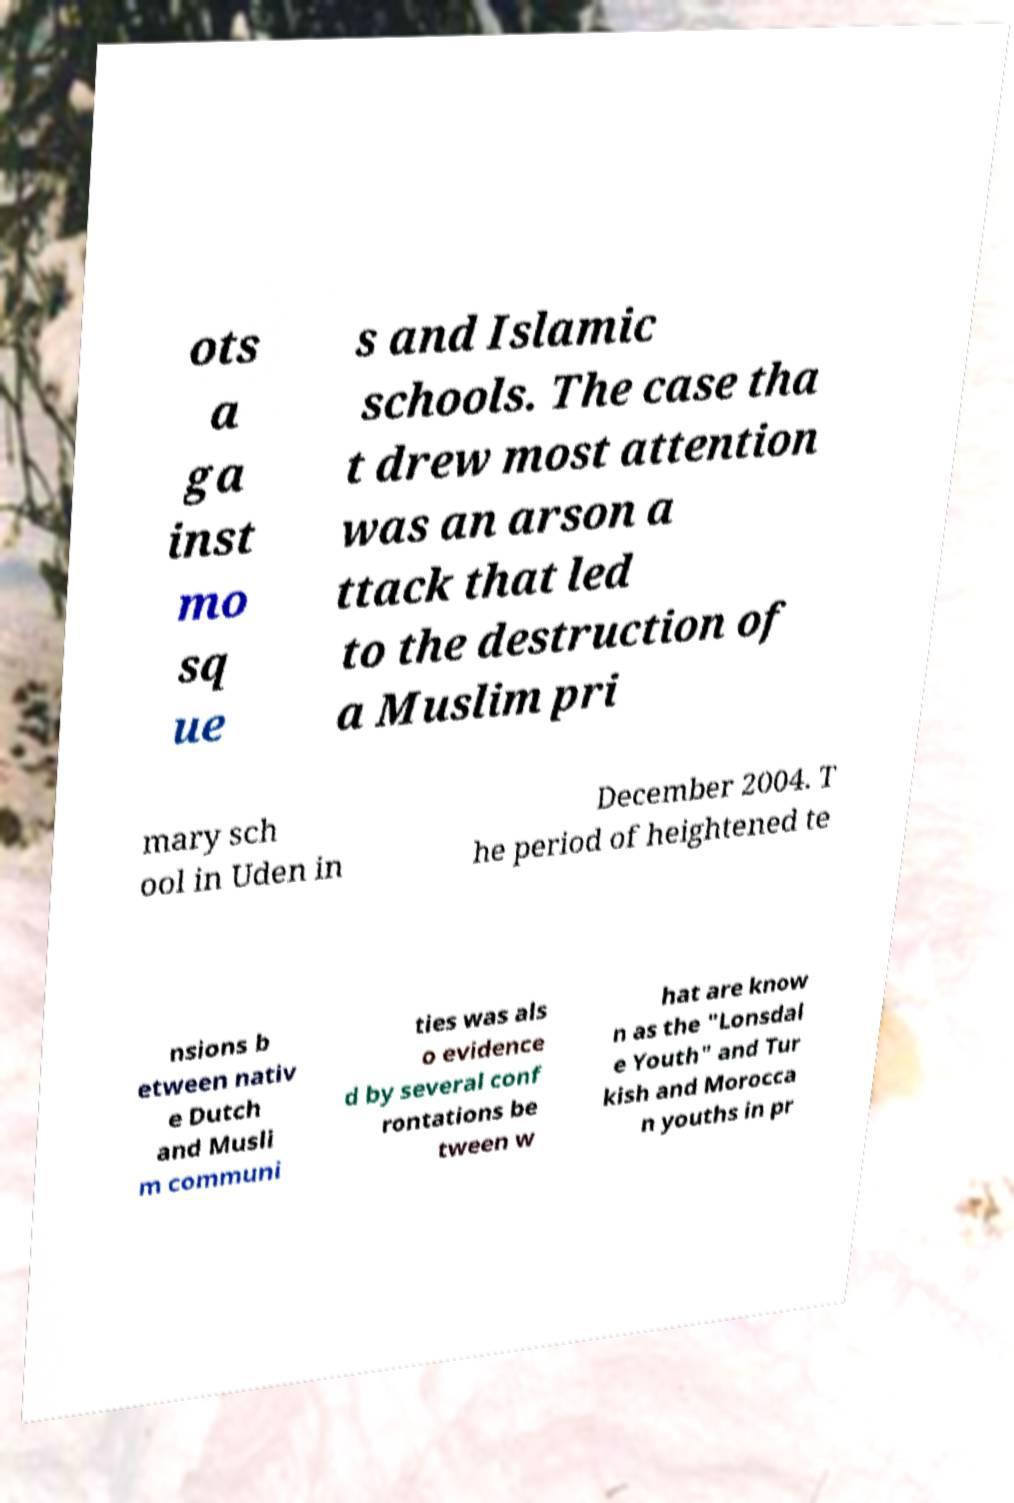For documentation purposes, I need the text within this image transcribed. Could you provide that? ots a ga inst mo sq ue s and Islamic schools. The case tha t drew most attention was an arson a ttack that led to the destruction of a Muslim pri mary sch ool in Uden in December 2004. T he period of heightened te nsions b etween nativ e Dutch and Musli m communi ties was als o evidence d by several conf rontations be tween w hat are know n as the "Lonsdal e Youth" and Tur kish and Morocca n youths in pr 